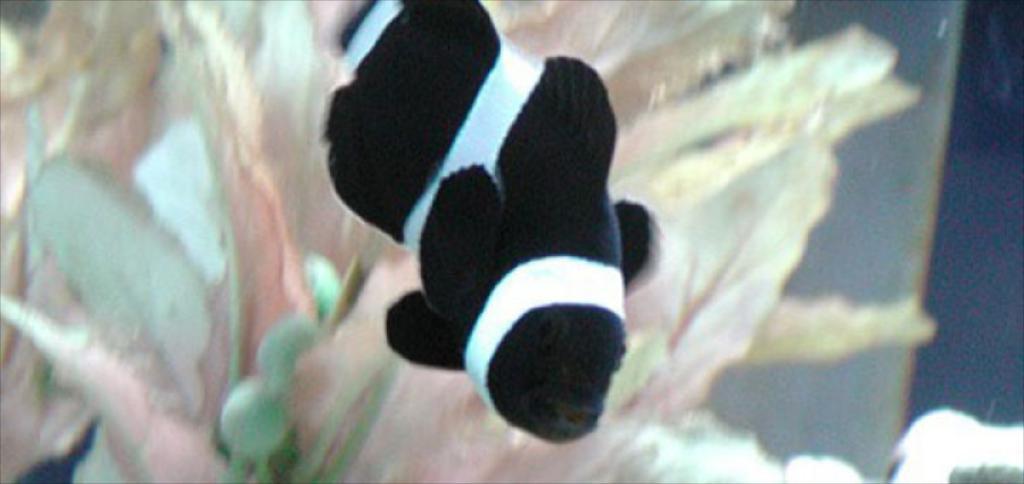Describe this image in one or two sentences. In this picture I can see there is a fish swimming and it has fins, mouth, nose and eyes. In the backdrop there is an aquatic plant. 